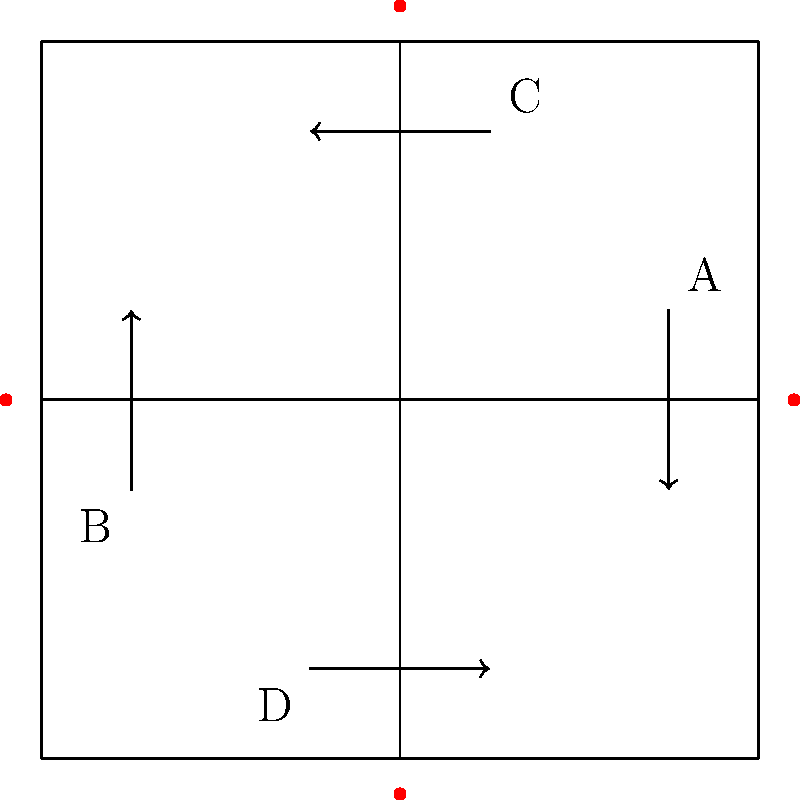As an inclusive tech designer, you're tasked with optimizing traffic flow at a four-way intersection. Given that lanes A and C experience 40% more traffic than lanes B and D during peak hours, how would you adjust the green light duration for each lane pair (A-C and B-D) to minimize wait times while ensuring fairness? Assume a total cycle time of 120 seconds and a minimum green light duration of 20 seconds for any lane pair. To optimize traffic flow while ensuring inclusivity and fairness, we need to consider both the traffic volume and the minimum green light duration for each lane pair. Let's approach this step-by-step:

1. Understand the given information:
   - Total cycle time: 120 seconds
   - Minimum green light duration for any lane pair: 20 seconds
   - Lanes A and C have 40% more traffic than lanes B and D

2. Calculate the traffic ratio between A-C and B-D:
   - Let x be the traffic volume for B-D
   - Then, 1.4x is the traffic volume for A-C
   - The ratio of A-C to B-D is 1.4x : x, which simplifies to 1.4 : 1

3. Divide the available time proportionally:
   - Total available time = 120 seconds
   - Time ratio for A-C : B-D = 1.4 : 1
   - Total parts = 1.4 + 1 = 2.4

4. Calculate the initial time allocation:
   - Time for A-C = (1.4 / 2.4) * 120 = 70 seconds
   - Time for B-D = (1 / 2.4) * 120 = 50 seconds

5. Check if the minimum green light duration is met:
   - Both A-C (70s) and B-D (50s) exceed the minimum of 20 seconds

6. Final time allocation:
   - Green light duration for A-C: 70 seconds
   - Green light duration for B-D: 50 seconds

This solution optimizes traffic flow by allocating more time to the busier lanes (A-C) while still providing adequate time for the less busy lanes (B-D). It ensures fairness by considering the traffic volume difference and maintaining a minimum green light duration for all lanes.
Answer: A-C: 70 seconds, B-D: 50 seconds 